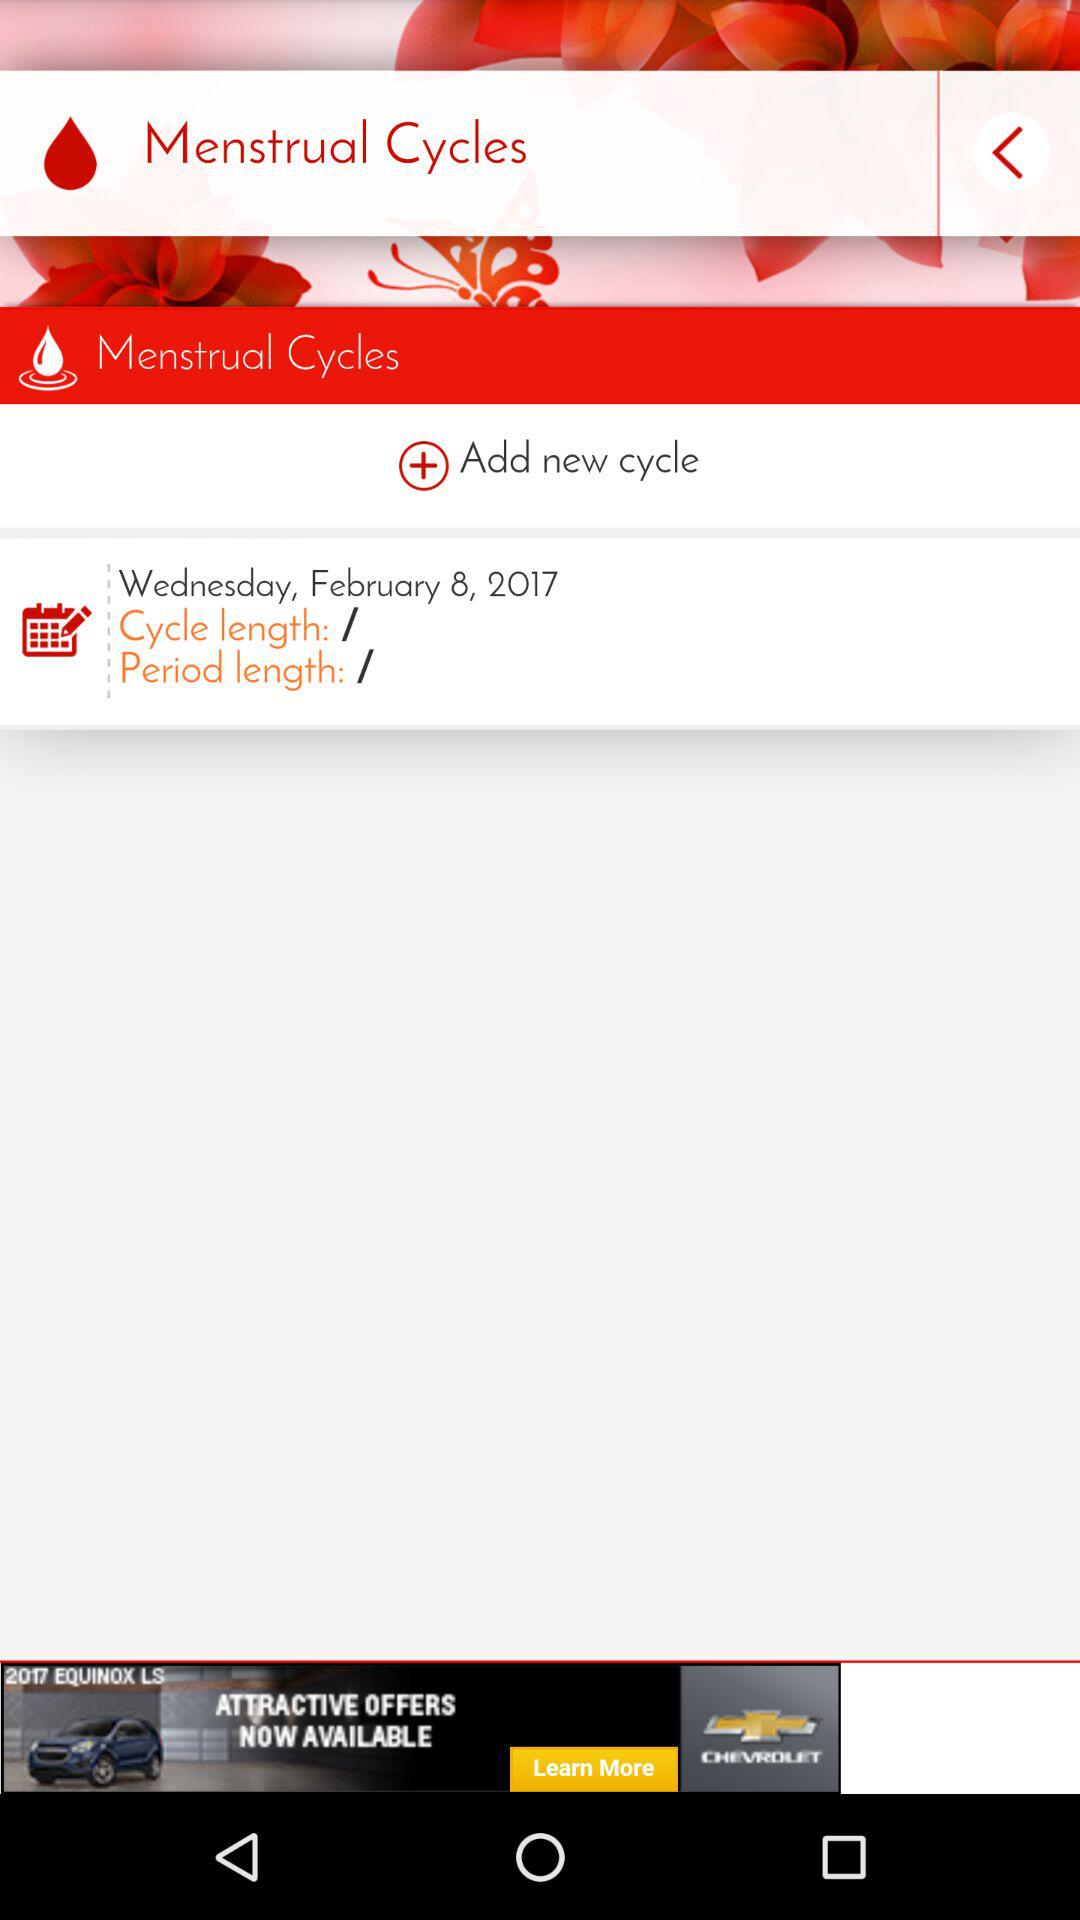What is the upcoming cycle date? The upcoming cycle date is Wednesday, February 8, 2017. 